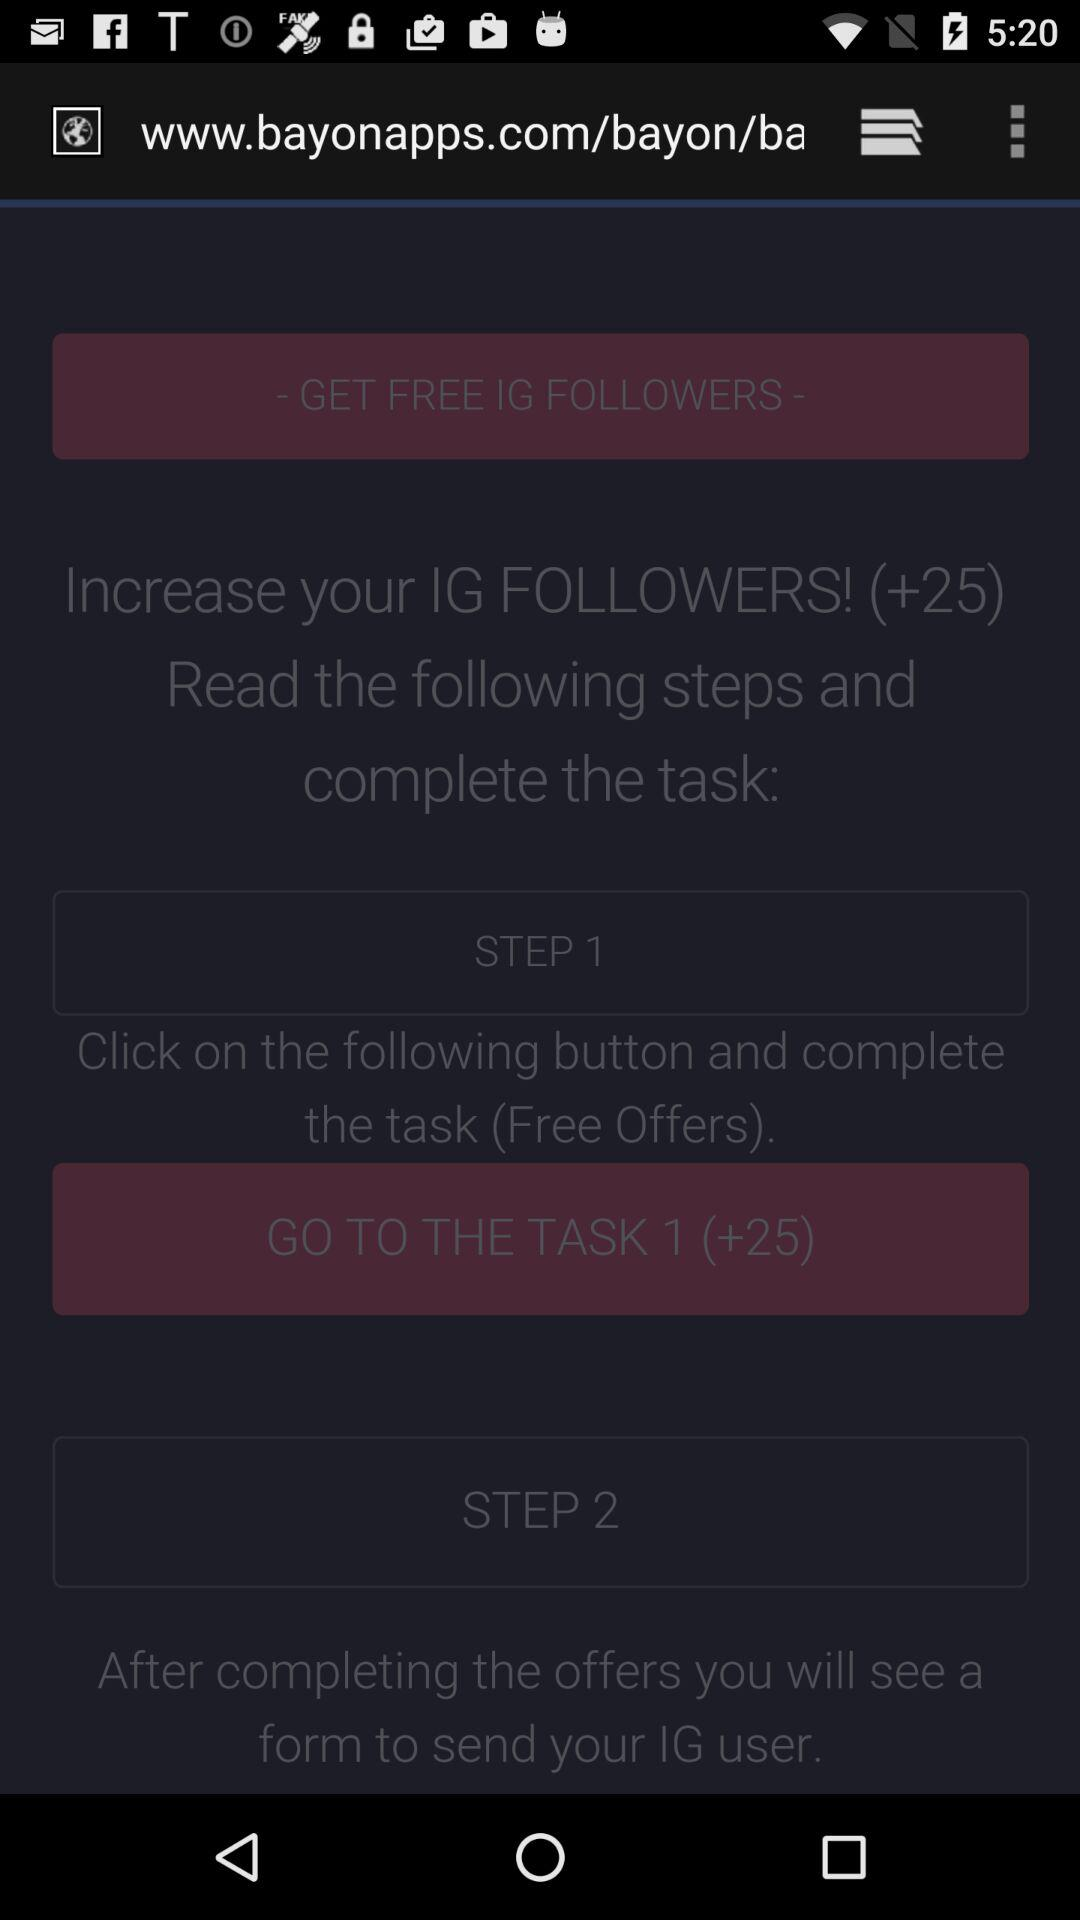How many steps are there in the process?
Answer the question using a single word or phrase. 2 